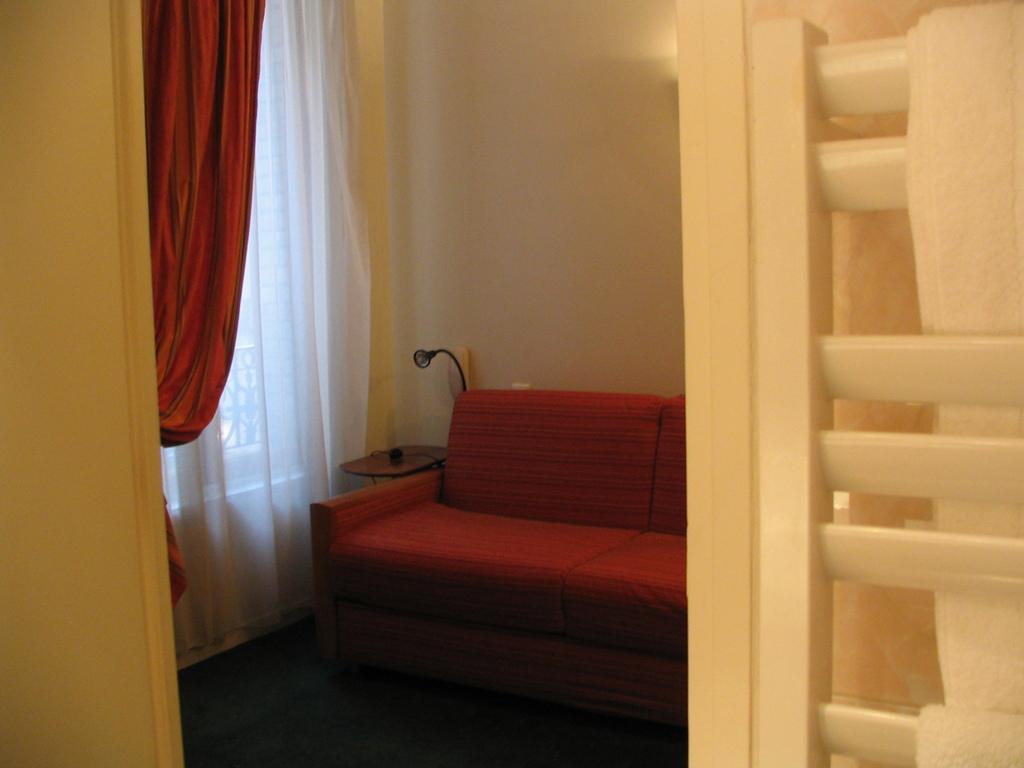Please provide a concise description of this image. In this image we can see a sofa in the room and curtains. 